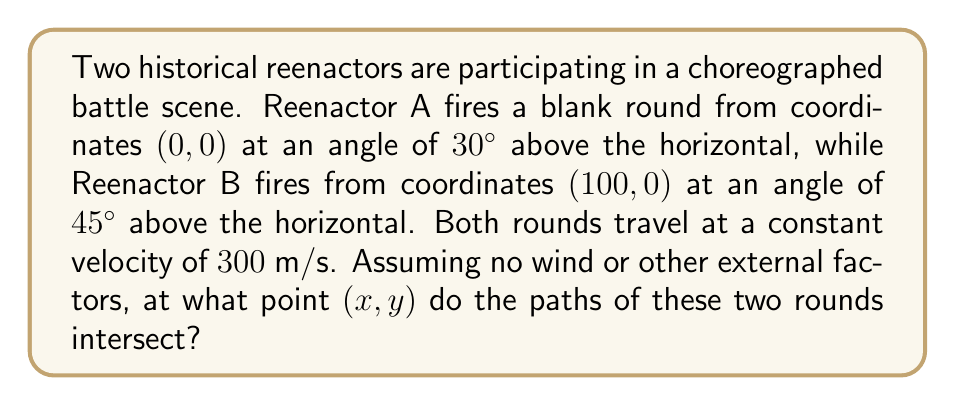Teach me how to tackle this problem. Let's approach this step-by-step:

1) First, we need to set up equations for the paths of both rounds. We can use the parametric equations of motion:

   For Reenactor A:
   $$x_A = 300t \cos(30°)$$
   $$y_A = 300t \sin(30°) - 4.9t^2$$

   For Reenactor B:
   $$x_B = 100 + 300t \cos(45°)$$
   $$y_B = 300t \sin(45°) - 4.9t^2$$

2) At the intersection point, $x_A = x_B$ and $y_A = y_B$. Let's equate these:

   $$300t_A \cos(30°) = 100 + 300t_B \cos(45°)$$
   $$300t_A \sin(30°) - 4.9t_A^2 = 300t_B \sin(45°) - 4.9t_B^2$$

3) Simplify using known trigonometric values:

   $$259.8t_A = 100 + 212.1t_B$$
   $$150t_A - 4.9t_A^2 = 212.1t_B - 4.9t_B^2$$

4) From the first equation:
   $$t_A = \frac{100 + 212.1t_B}{259.8}$$

5) Substitute this into the second equation:

   $$150(\frac{100 + 212.1t_B}{259.8}) - 4.9(\frac{100 + 212.1t_B}{259.8})^2 = 212.1t_B - 4.9t_B^2$$

6) Solve this equation numerically (it's a quadratic in $t_B$). We get:

   $$t_B \approx 0.3287 \text{ seconds}$$

7) Substitute back to find $t_A$:

   $$t_A \approx 0.3775 \text{ seconds}$$

8) Use either set of parametric equations to find the intersection point:

   $$x = 300 * 0.3775 * \cos(30°) \approx 98.1 \text{ meters}$$
   $$y = 300 * 0.3775 * \sin(30°) - 4.9 * 0.3775^2 \approx 52.7 \text{ meters}$$
Answer: (98.1, 52.7) meters 